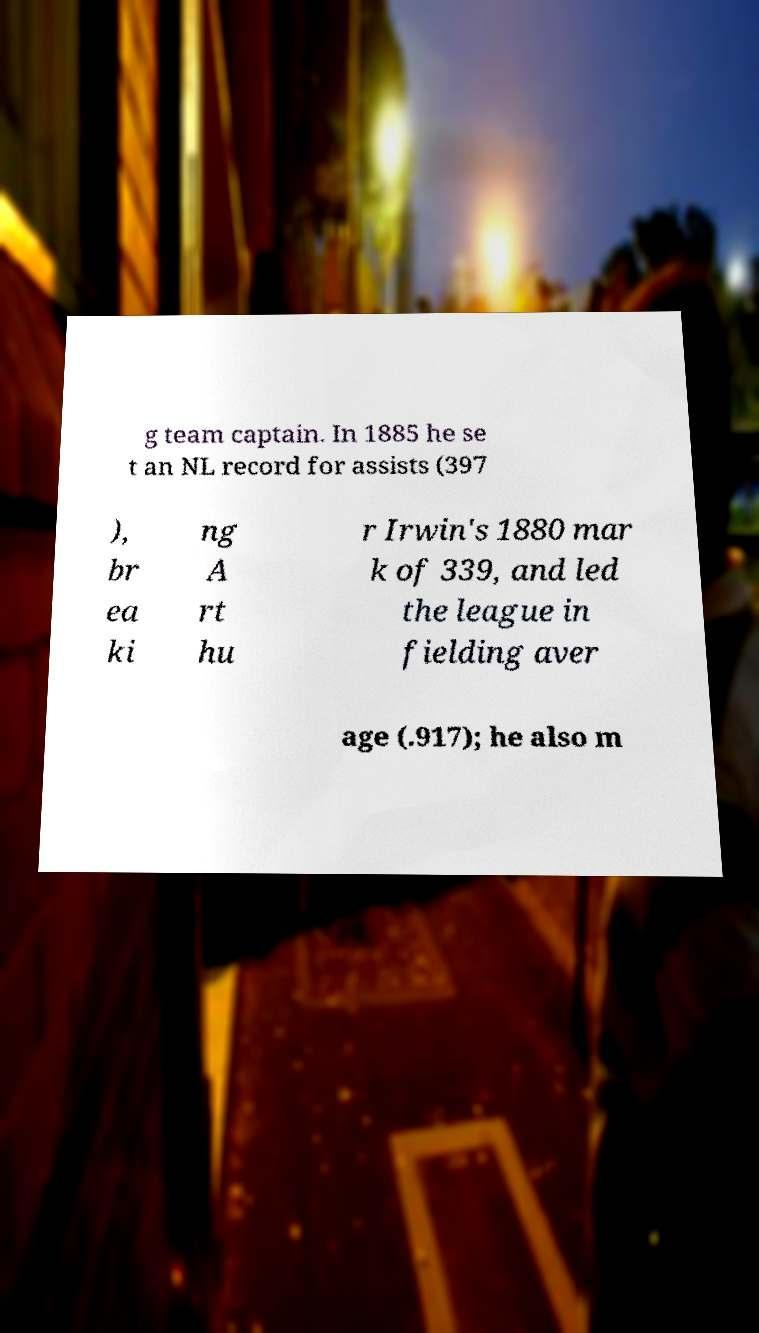There's text embedded in this image that I need extracted. Can you transcribe it verbatim? g team captain. In 1885 he se t an NL record for assists (397 ), br ea ki ng A rt hu r Irwin's 1880 mar k of 339, and led the league in fielding aver age (.917); he also m 